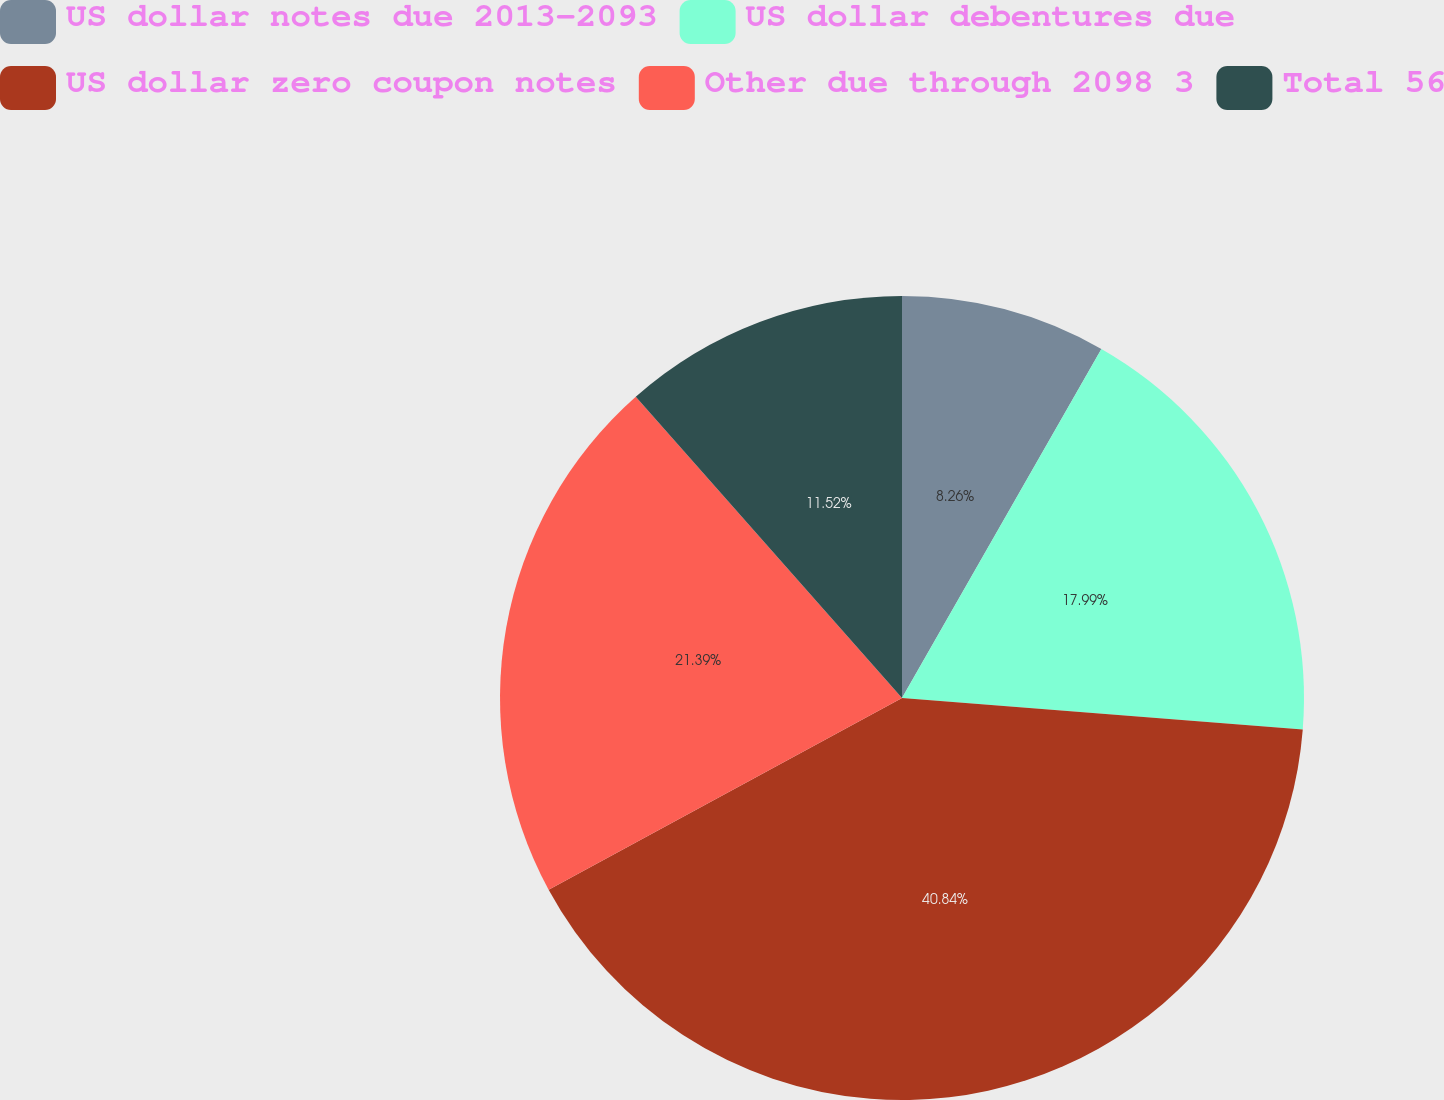<chart> <loc_0><loc_0><loc_500><loc_500><pie_chart><fcel>US dollar notes due 2013-2093<fcel>US dollar debentures due<fcel>US dollar zero coupon notes<fcel>Other due through 2098 3<fcel>Total 56<nl><fcel>8.26%<fcel>17.99%<fcel>40.84%<fcel>21.39%<fcel>11.52%<nl></chart> 